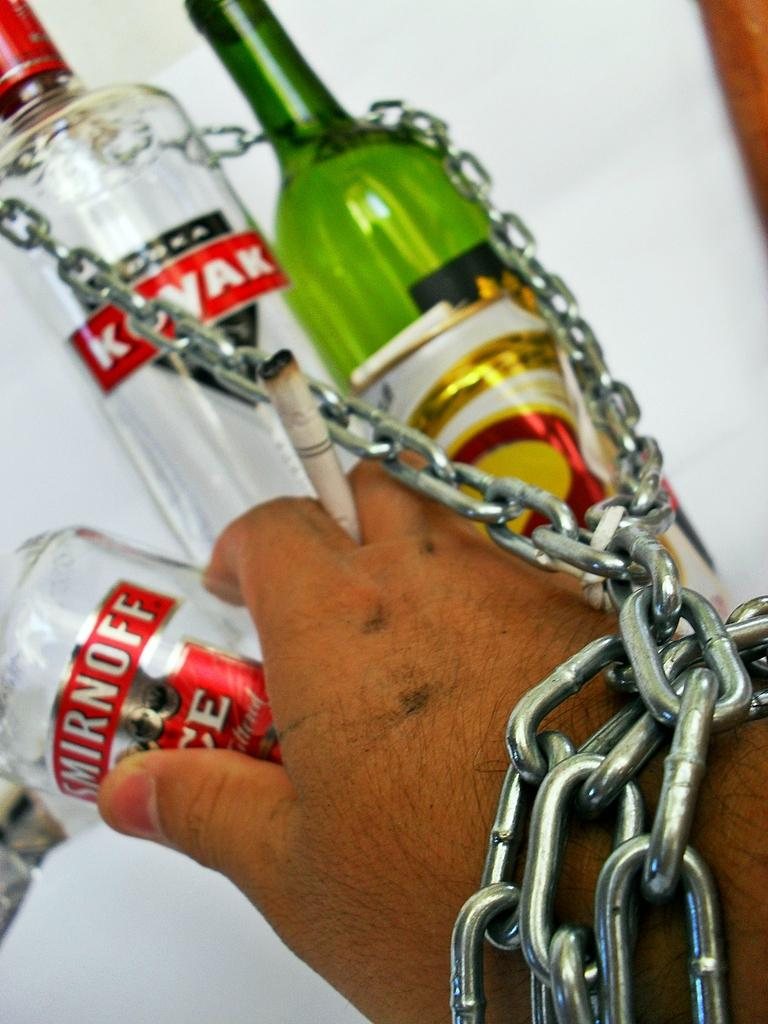What is the person holding in the image? The hand of a person is holding a cigarette in the image. What other object can be seen in the image? There is a chain in the image. What else is present in the image besides the hand and the chain? There are bottles in the image. What is the baby doing in the image? There is no baby present in the image. 